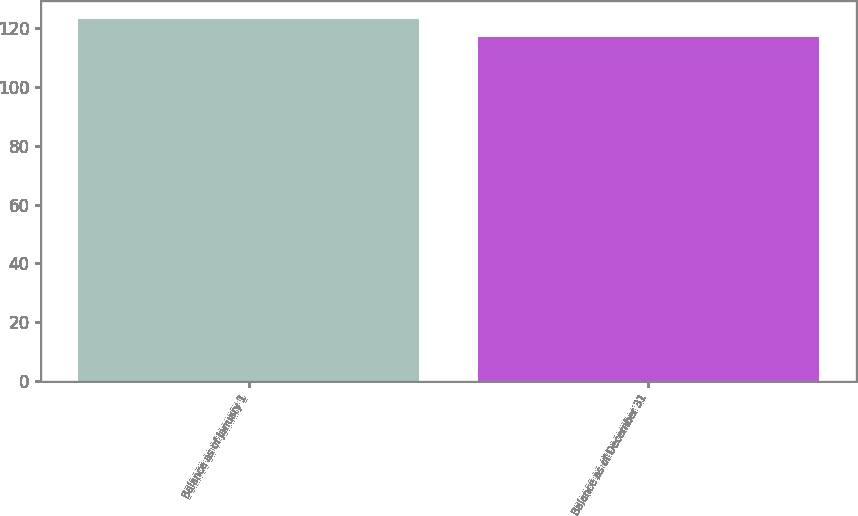Convert chart to OTSL. <chart><loc_0><loc_0><loc_500><loc_500><bar_chart><fcel>Balance as of January 1<fcel>Balance as of December 31<nl><fcel>123<fcel>117<nl></chart> 